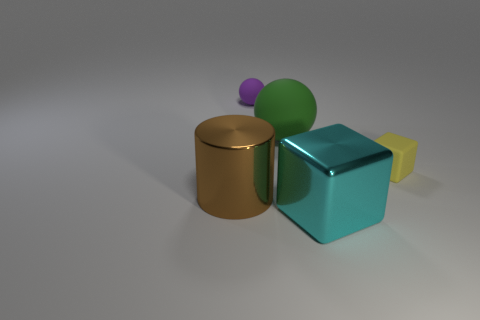Subtract all red balls. Subtract all brown cubes. How many balls are left? 2 Add 1 blocks. How many objects exist? 6 Subtract all cylinders. How many objects are left? 4 Subtract 0 yellow cylinders. How many objects are left? 5 Subtract all large yellow shiny spheres. Subtract all big brown cylinders. How many objects are left? 4 Add 4 purple things. How many purple things are left? 5 Add 3 big blue metallic cylinders. How many big blue metallic cylinders exist? 3 